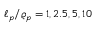<formula> <loc_0><loc_0><loc_500><loc_500>\ell _ { p } / \varrho _ { p } = 1 , 2 . 5 , 5 , 1 0</formula> 